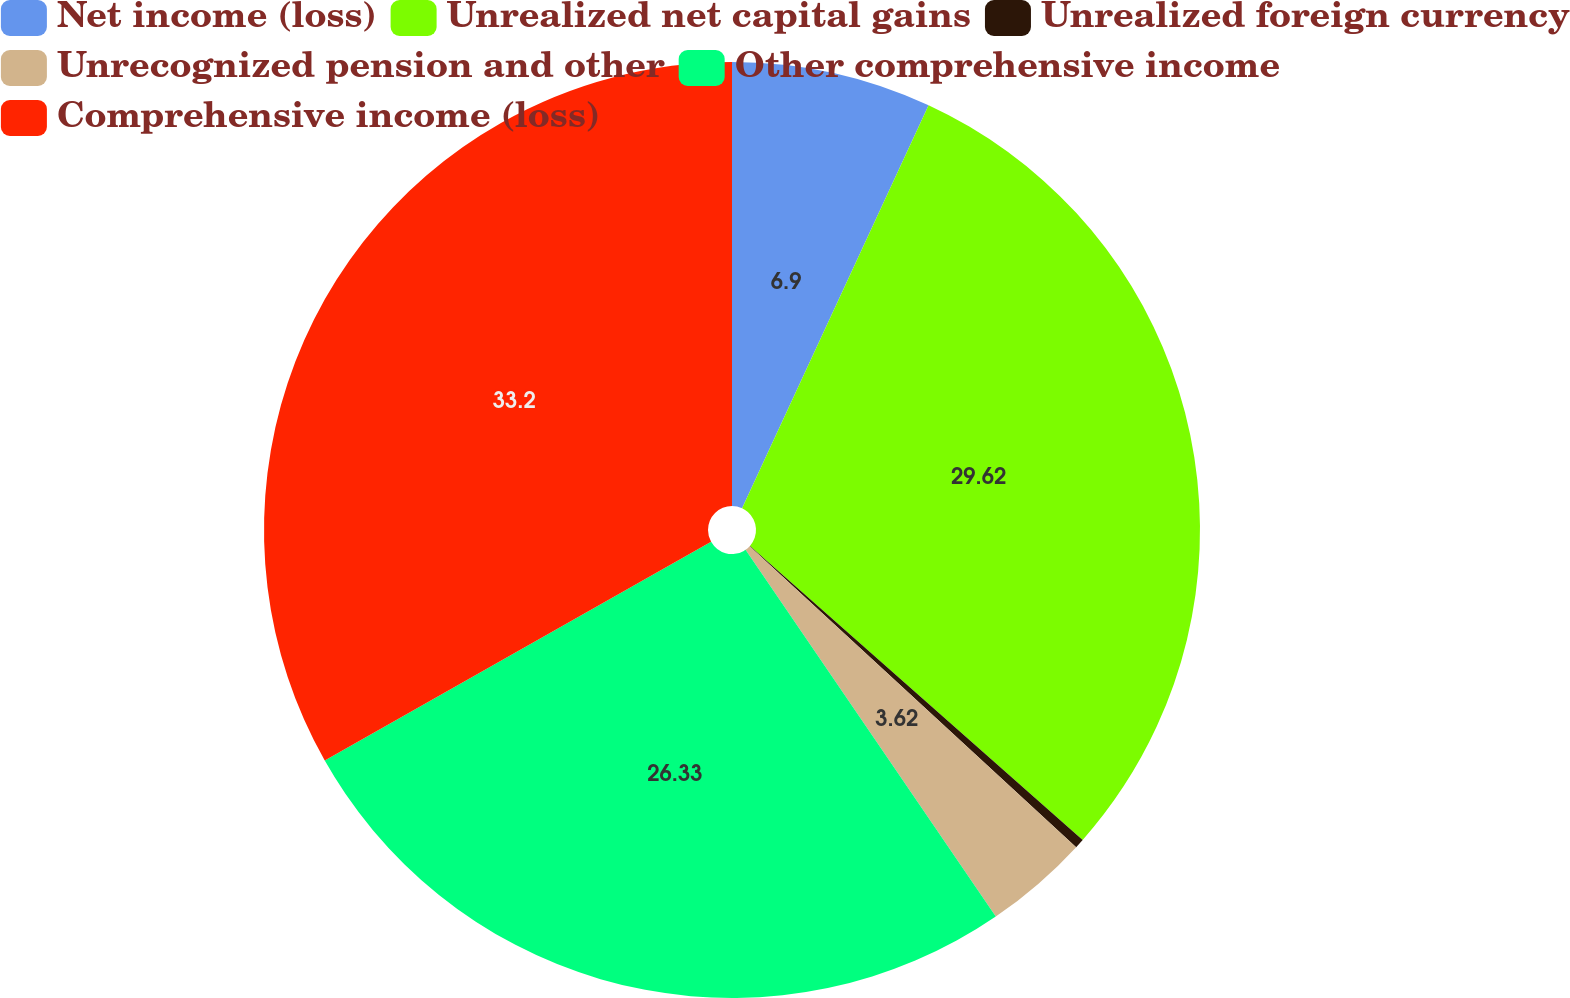Convert chart. <chart><loc_0><loc_0><loc_500><loc_500><pie_chart><fcel>Net income (loss)<fcel>Unrealized net capital gains<fcel>Unrealized foreign currency<fcel>Unrecognized pension and other<fcel>Other comprehensive income<fcel>Comprehensive income (loss)<nl><fcel>6.9%<fcel>29.62%<fcel>0.33%<fcel>3.62%<fcel>26.33%<fcel>33.2%<nl></chart> 